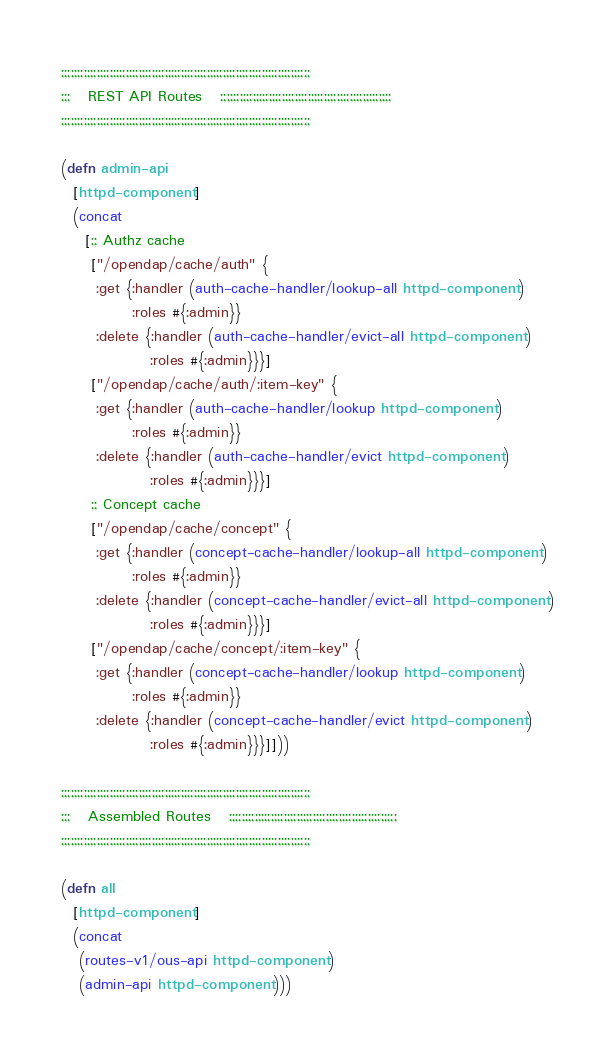Convert code to text. <code><loc_0><loc_0><loc_500><loc_500><_Clojure_>
;;;;;;;;;;;;;;;;;;;;;;;;;;;;;;;;;;;;;;;;;;;;;;;;;;;;;;;;;;;;;;;;;;;;;;;;;;;;;
;;;   REST API Routes   ;;;;;;;;;;;;;;;;;;;;;;;;;;;;;;;;;;;;;;;;;;;;;;;;;;;;;
;;;;;;;;;;;;;;;;;;;;;;;;;;;;;;;;;;;;;;;;;;;;;;;;;;;;;;;;;;;;;;;;;;;;;;;;;;;;;

(defn admin-api
  [httpd-component]
  (concat
    [;; Authz cache
     ["/opendap/cache/auth" {
      :get {:handler (auth-cache-handler/lookup-all httpd-component)
            :roles #{:admin}}
      :delete {:handler (auth-cache-handler/evict-all httpd-component)
               :roles #{:admin}}}]
     ["/opendap/cache/auth/:item-key" {
      :get {:handler (auth-cache-handler/lookup httpd-component)
            :roles #{:admin}}
      :delete {:handler (auth-cache-handler/evict httpd-component)
               :roles #{:admin}}}]
     ;; Concept cache
     ["/opendap/cache/concept" {
      :get {:handler (concept-cache-handler/lookup-all httpd-component)
            :roles #{:admin}}
      :delete {:handler (concept-cache-handler/evict-all httpd-component)
               :roles #{:admin}}}]
     ["/opendap/cache/concept/:item-key" {
      :get {:handler (concept-cache-handler/lookup httpd-component)
            :roles #{:admin}}
      :delete {:handler (concept-cache-handler/evict httpd-component)
               :roles #{:admin}}}]]))

;;;;;;;;;;;;;;;;;;;;;;;;;;;;;;;;;;;;;;;;;;;;;;;;;;;;;;;;;;;;;;;;;;;;;;;;;;;;;
;;;   Assembled Routes   ;;;;;;;;;;;;;;;;;;;;;;;;;;;;;;;;;;;;;;;;;;;;;;;;;;;;
;;;;;;;;;;;;;;;;;;;;;;;;;;;;;;;;;;;;;;;;;;;;;;;;;;;;;;;;;;;;;;;;;;;;;;;;;;;;;

(defn all
  [httpd-component]
  (concat
   (routes-v1/ous-api httpd-component)
   (admin-api httpd-component)))
</code> 